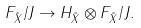<formula> <loc_0><loc_0><loc_500><loc_500>F _ { \tilde { X } } / J \to H _ { \tilde { X } } \otimes F _ { \tilde { X } } / J .</formula> 